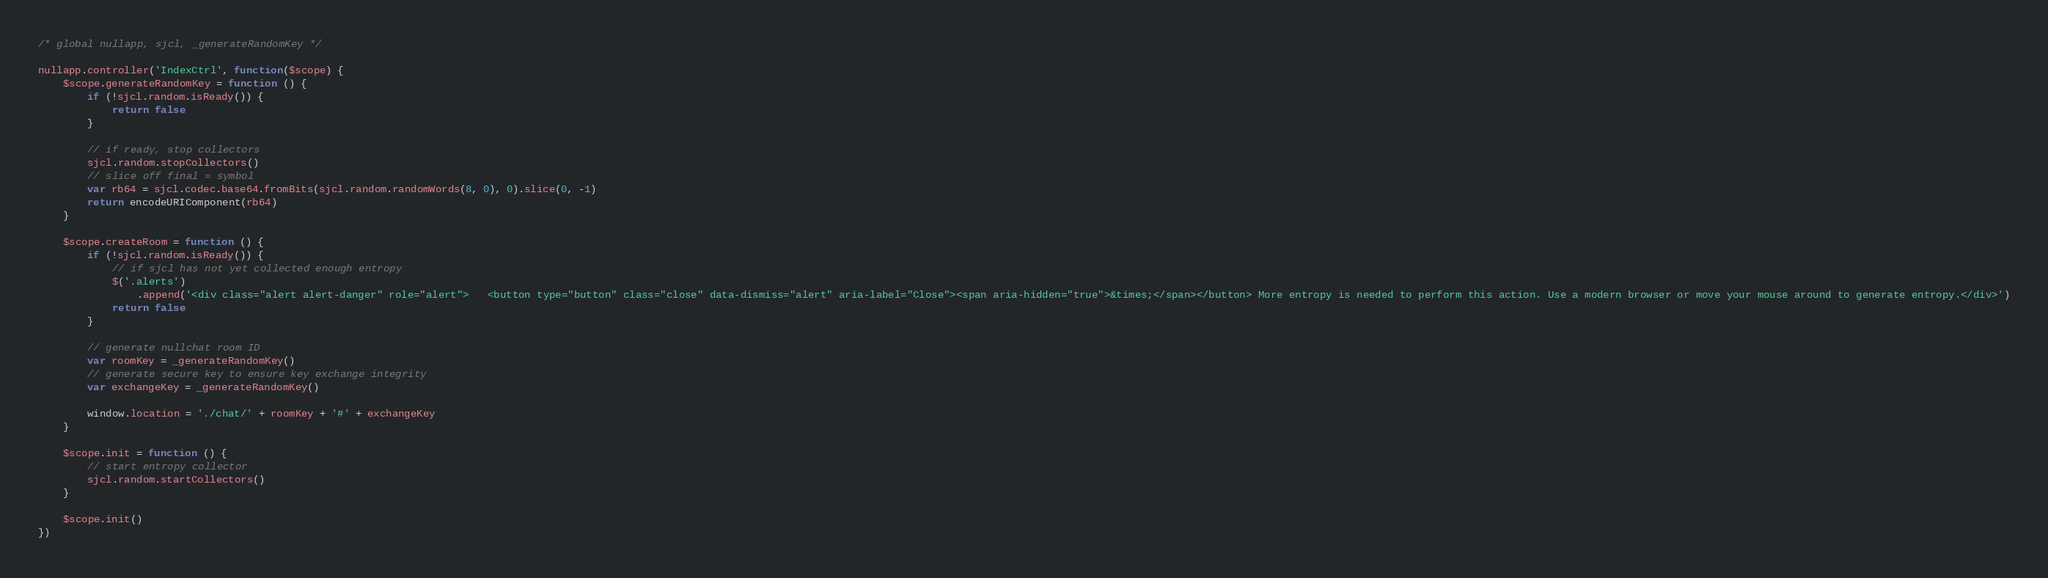Convert code to text. <code><loc_0><loc_0><loc_500><loc_500><_JavaScript_>/* global nullapp, sjcl, _generateRandomKey */

nullapp.controller('IndexCtrl', function($scope) {
    $scope.generateRandomKey = function () {
        if (!sjcl.random.isReady()) {
            return false
        }

        // if ready, stop collectors
        sjcl.random.stopCollectors()
        // slice off final = symbol
        var rb64 = sjcl.codec.base64.fromBits(sjcl.random.randomWords(8, 0), 0).slice(0, -1)
        return encodeURIComponent(rb64)
    }

    $scope.createRoom = function () {
        if (!sjcl.random.isReady()) {
            // if sjcl has not yet collected enough entropy
            $('.alerts')
                .append('<div class="alert alert-danger" role="alert">   <button type="button" class="close" data-dismiss="alert" aria-label="Close"><span aria-hidden="true">&times;</span></button> More entropy is needed to perform this action. Use a modern browser or move your mouse around to generate entropy.</div>')
            return false
        }

        // generate nullchat room ID
        var roomKey = _generateRandomKey()
        // generate secure key to ensure key exchange integrity
        var exchangeKey = _generateRandomKey()

        window.location = './chat/' + roomKey + '#' + exchangeKey
    }

    $scope.init = function () {
        // start entropy collector
        sjcl.random.startCollectors()
    }

    $scope.init()
})
</code> 